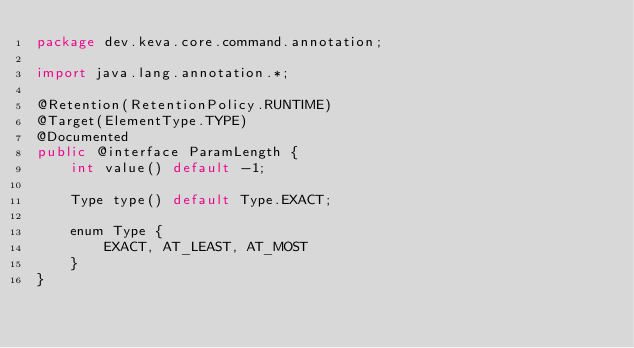Convert code to text. <code><loc_0><loc_0><loc_500><loc_500><_Java_>package dev.keva.core.command.annotation;

import java.lang.annotation.*;

@Retention(RetentionPolicy.RUNTIME)
@Target(ElementType.TYPE)
@Documented
public @interface ParamLength {
    int value() default -1;

    Type type() default Type.EXACT;

    enum Type {
        EXACT, AT_LEAST, AT_MOST
    }
}
</code> 